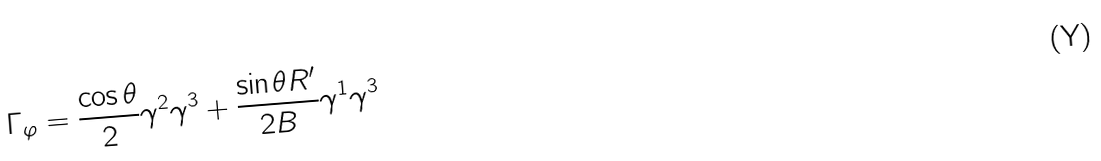<formula> <loc_0><loc_0><loc_500><loc_500>\Gamma _ { \varphi } = \frac { \cos \theta } { 2 } \gamma ^ { 2 } \gamma ^ { 3 } + \frac { \sin \theta R ^ { \prime } } { 2 B } \gamma ^ { 1 } \gamma ^ { 3 }</formula> 